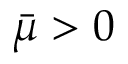<formula> <loc_0><loc_0><loc_500><loc_500>\bar { \mu } > 0</formula> 